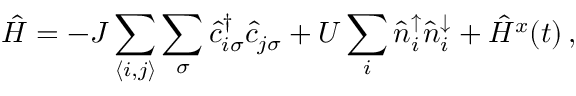Convert formula to latex. <formula><loc_0><loc_0><loc_500><loc_500>\hat { H } = - J \sum _ { \langle i , j \rangle } \sum _ { \sigma } \hat { c } _ { i \sigma } ^ { \dagger } \hat { c } _ { j \sigma } + U \sum _ { i } \hat { n } _ { i } ^ { \uparrow } \hat { n } _ { i } ^ { \downarrow } + \hat { H } ^ { x } ( t ) \, ,</formula> 